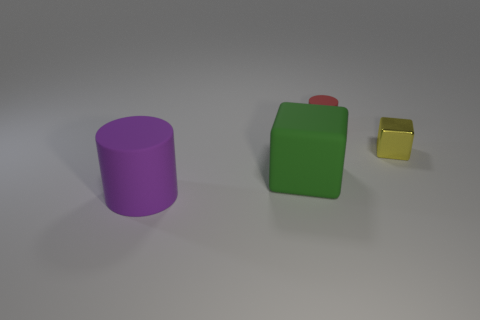There is another object that is the same shape as the red thing; what is it made of?
Provide a short and direct response. Rubber. There is a tiny shiny object; is it the same shape as the large rubber object right of the large purple cylinder?
Provide a short and direct response. Yes. How many things are to the left of the red matte cylinder?
Make the answer very short. 2. Is there another metal block that has the same size as the yellow metal cube?
Make the answer very short. No. Does the object that is to the left of the large green block have the same shape as the small metallic thing?
Offer a very short reply. No. The small shiny object is what color?
Provide a short and direct response. Yellow. Is there a purple matte thing?
Provide a short and direct response. Yes. What is the size of the red cylinder that is the same material as the big green object?
Offer a very short reply. Small. There is a green rubber thing that is in front of the small thing in front of the matte cylinder behind the metallic thing; what is its shape?
Your answer should be very brief. Cube. Are there an equal number of green objects in front of the purple matte thing and small green matte objects?
Your answer should be very brief. Yes. 